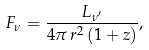Convert formula to latex. <formula><loc_0><loc_0><loc_500><loc_500>F _ { \nu } = \frac { L _ { \nu ^ { \prime } } } { 4 \pi \, r ^ { 2 } \, ( 1 + z ) } ,</formula> 